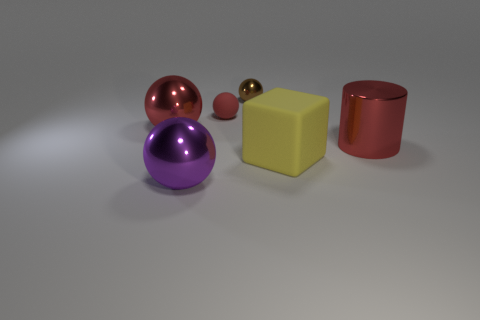Subtract all red metallic balls. How many balls are left? 3 Subtract all cylinders. How many objects are left? 5 Subtract all red spheres. How many spheres are left? 2 Subtract all red spheres. How many cyan cubes are left? 0 Subtract all large cyan shiny objects. Subtract all tiny brown metallic spheres. How many objects are left? 5 Add 6 big red metal cylinders. How many big red metal cylinders are left? 7 Add 4 red rubber objects. How many red rubber objects exist? 5 Add 4 large yellow things. How many objects exist? 10 Subtract 0 green blocks. How many objects are left? 6 Subtract 1 spheres. How many spheres are left? 3 